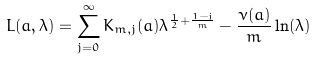Convert formula to latex. <formula><loc_0><loc_0><loc_500><loc_500>L ( a , \lambda ) = \sum _ { j = 0 } ^ { \infty } K _ { m , j } ( a ) \lambda ^ { \frac { 1 } { 2 } + \frac { 1 - j } { m } } - \frac { \nu ( a ) } { m } \ln ( \lambda )</formula> 